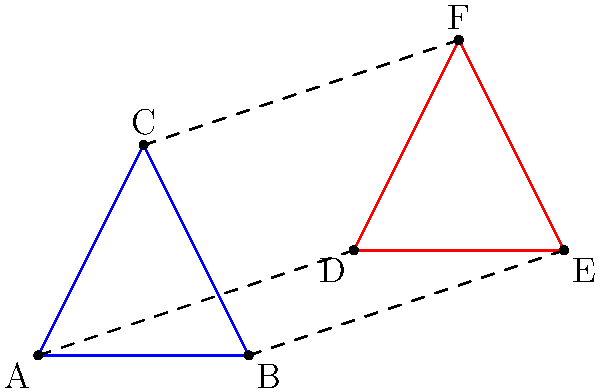In the context of Terrence Malick's visual style, which often emphasizes the interconnectedness of all things, consider the transformation of triangle ABC to triangle DEF. If this transformation represents the interconnectedness of characters in a Malick film, what single geometric transformation would best describe this change, and what does it symbolize about the characters' relationships? To answer this question, let's analyze the transformation step-by-step:

1. Observe the relationship between the two triangles:
   - The sides of both triangles are parallel to each other.
   - The triangles appear to be the same size and shape.
   - Triangle DEF seems to be shifted upward and to the right of triangle ABC.

2. In geometric terms, this transformation is a translation:
   - A translation moves every point of a shape the same distance in the same direction.
   - Here, each vertex of triangle ABC has been moved the same distance and direction to form triangle DEF.

3. To find the translation vector:
   - Compare the coordinates of corresponding vertices:
     A(0,0) → D(3,1)
     B(2,0) → E(5,1)
     C(1,2) → F(4,3)
   - The translation vector is (3,1) for all vertices.

4. In the context of Malick's filmmaking:
   - Translation symbolizes a parallel journey or shared experience.
   - Characters, while distinct (separate triangles), move through the narrative in similar ways.
   - The preservation of shape suggests maintained individuality despite shared experiences.
   - The dashed lines connecting corresponding vertices represent the interconnectedness of characters' journeys.

5. This geometric representation aligns with Malick's style:
   - It visualizes the idea that characters, while on individual paths, are part of a greater, interconnected whole.
   - The parallel nature of the triangles reflects how Malick often portrays multiple storylines or characters experiencing similar themes simultaneously.
Answer: Translation; parallel journeys maintaining individuality within interconnected experiences. 